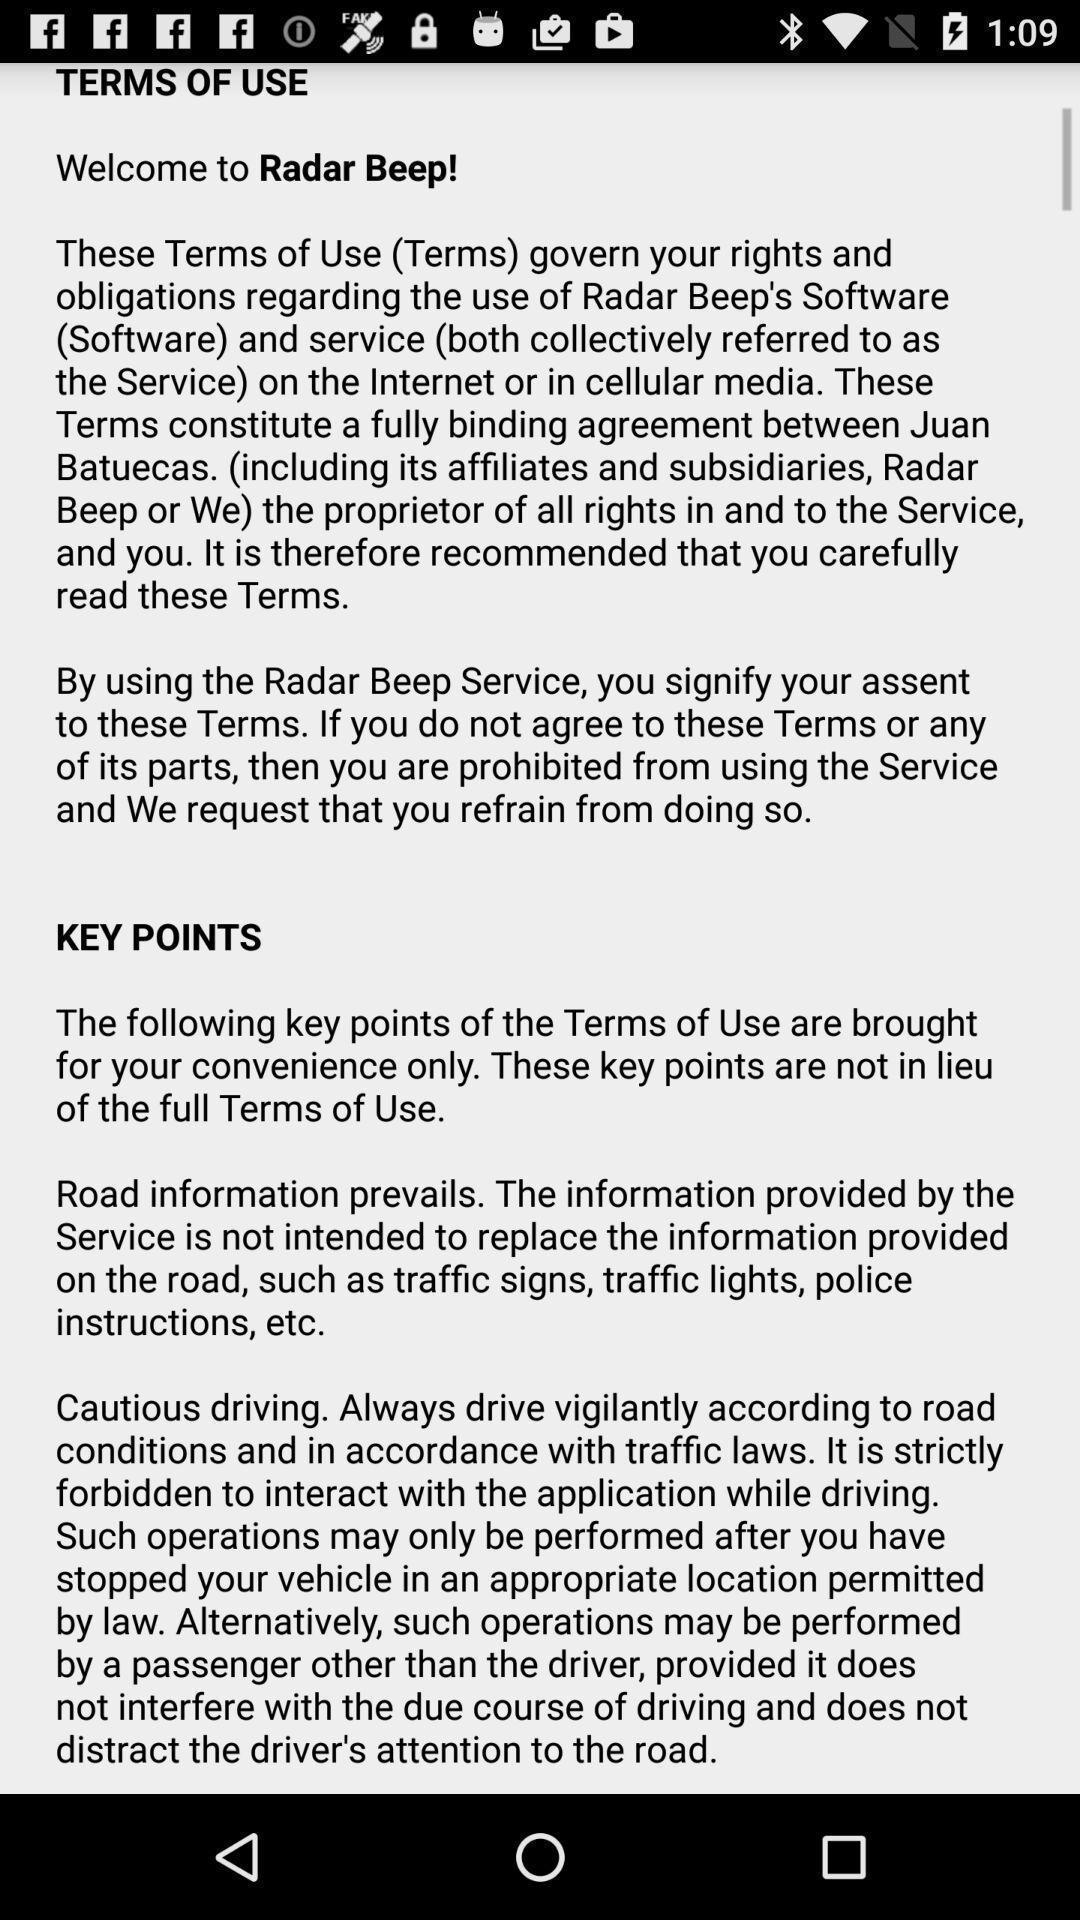Describe this image in words. Welcome page. 